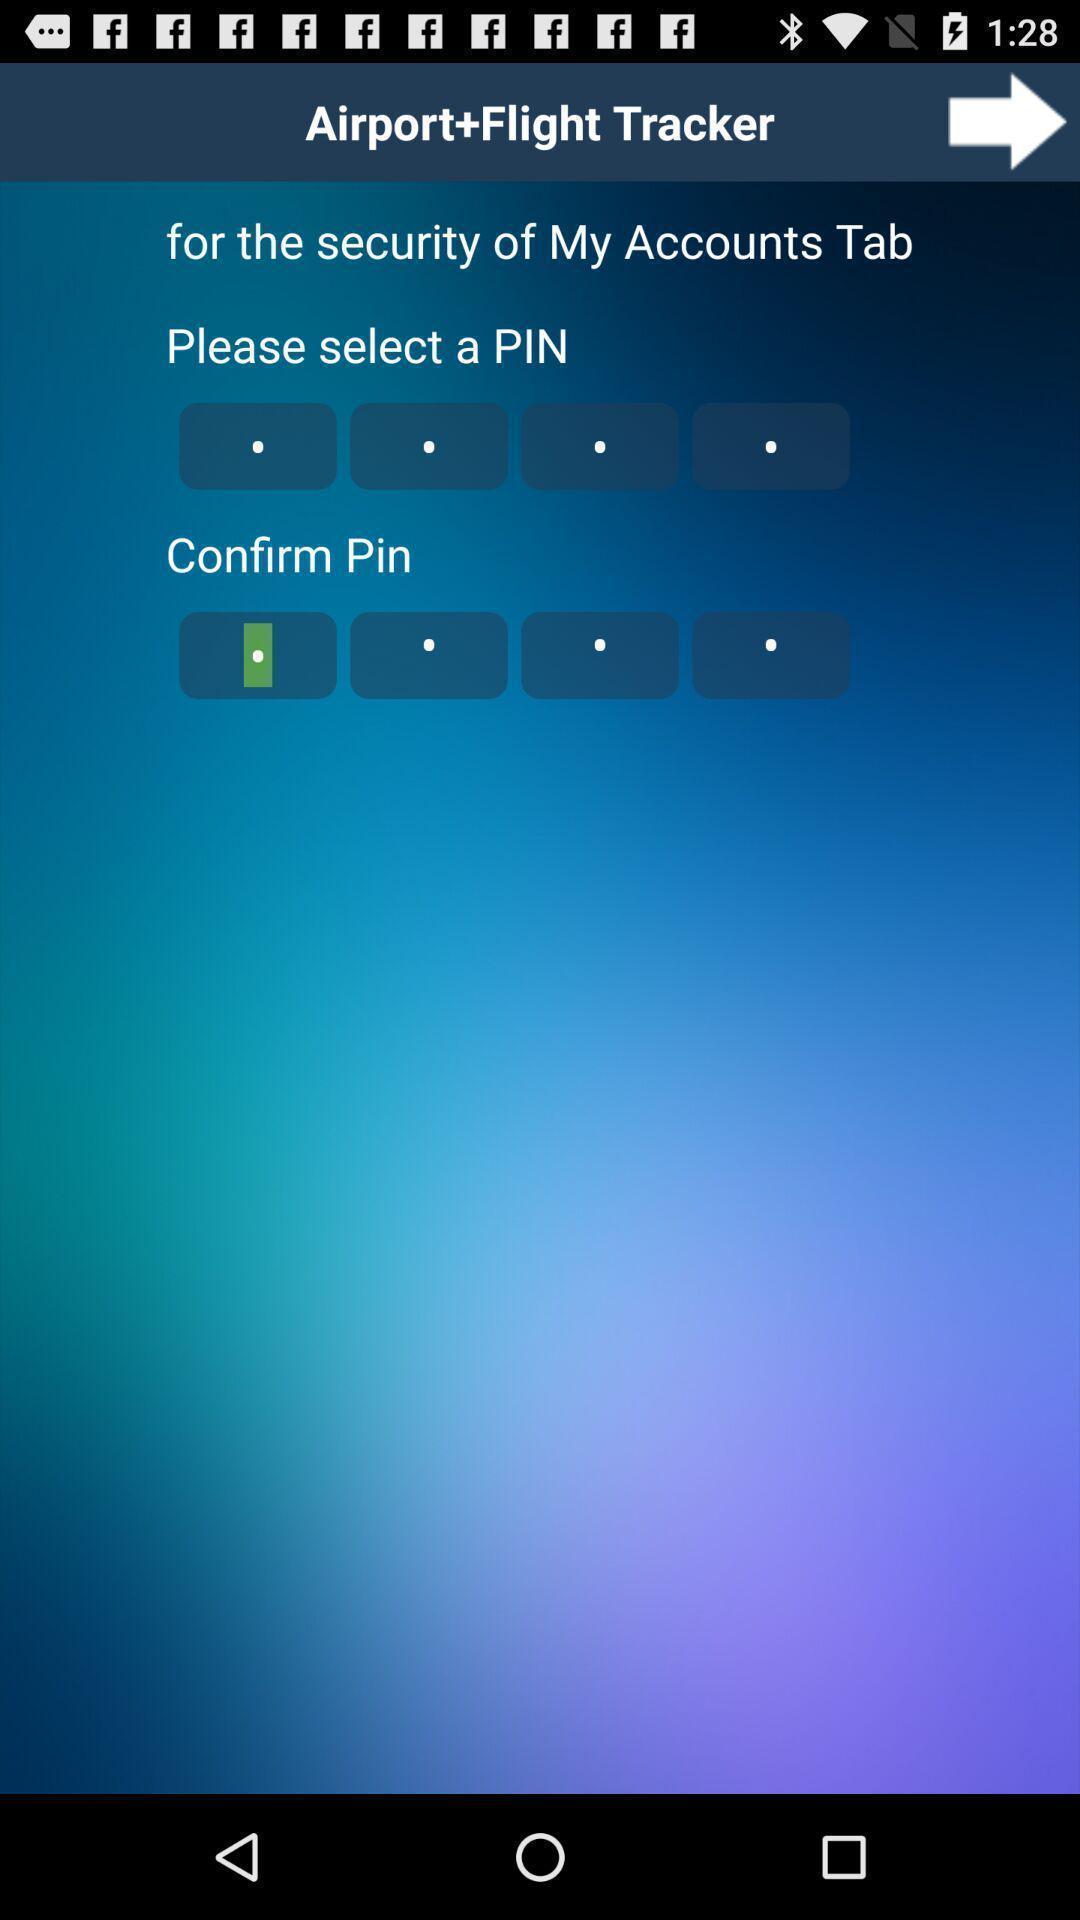Summarize the information in this screenshot. Screen shows details of a travel app. 